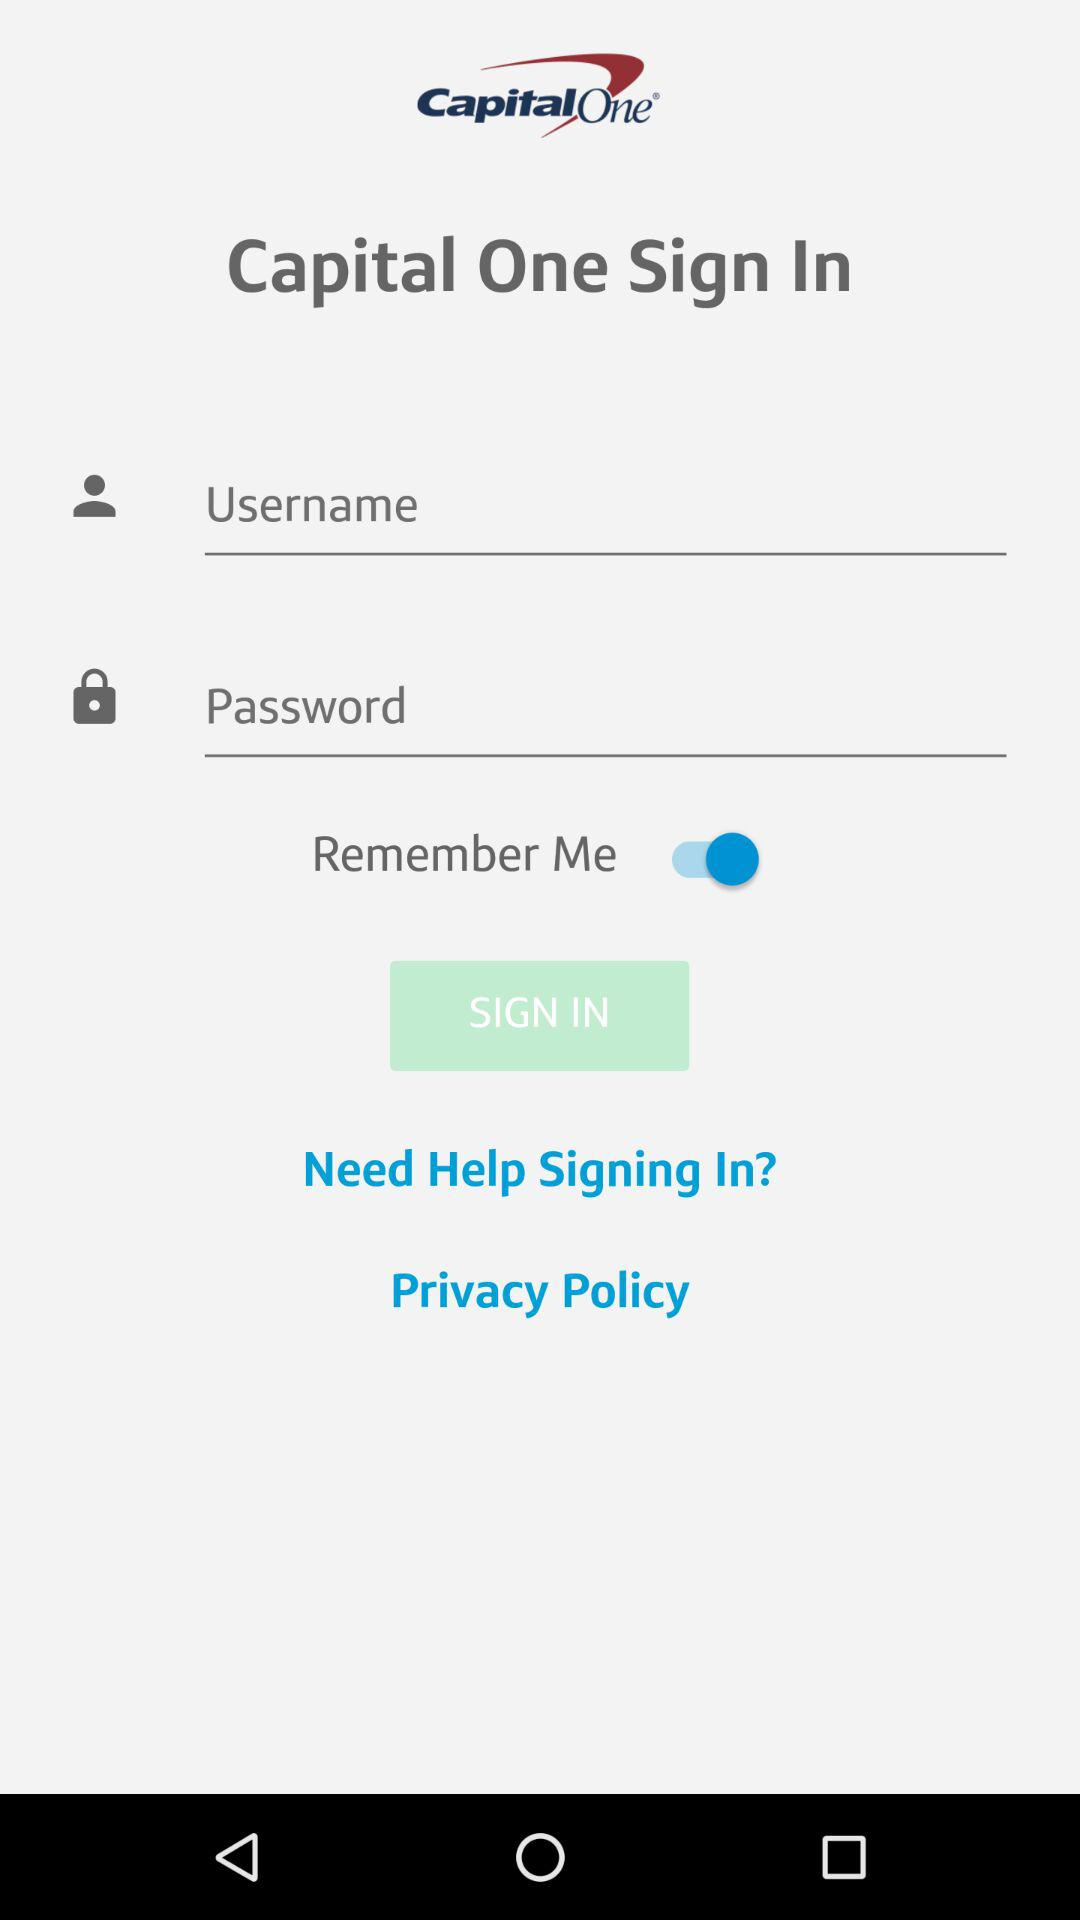What are the requirements to log in? The requirements to log in are the username and password. 